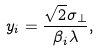<formula> <loc_0><loc_0><loc_500><loc_500>y _ { i } = \frac { \sqrt { 2 } \sigma _ { \perp } } { \beta _ { i } \lambda } ,</formula> 